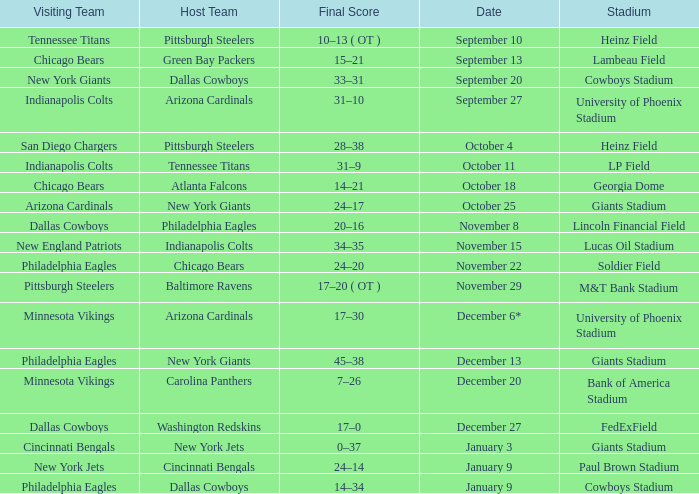Parse the table in full. {'header': ['Visiting Team', 'Host Team', 'Final Score', 'Date', 'Stadium'], 'rows': [['Tennessee Titans', 'Pittsburgh Steelers', '10–13 ( OT )', 'September 10', 'Heinz Field'], ['Chicago Bears', 'Green Bay Packers', '15–21', 'September 13', 'Lambeau Field'], ['New York Giants', 'Dallas Cowboys', '33–31', 'September 20', 'Cowboys Stadium'], ['Indianapolis Colts', 'Arizona Cardinals', '31–10', 'September 27', 'University of Phoenix Stadium'], ['San Diego Chargers', 'Pittsburgh Steelers', '28–38', 'October 4', 'Heinz Field'], ['Indianapolis Colts', 'Tennessee Titans', '31–9', 'October 11', 'LP Field'], ['Chicago Bears', 'Atlanta Falcons', '14–21', 'October 18', 'Georgia Dome'], ['Arizona Cardinals', 'New York Giants', '24–17', 'October 25', 'Giants Stadium'], ['Dallas Cowboys', 'Philadelphia Eagles', '20–16', 'November 8', 'Lincoln Financial Field'], ['New England Patriots', 'Indianapolis Colts', '34–35', 'November 15', 'Lucas Oil Stadium'], ['Philadelphia Eagles', 'Chicago Bears', '24–20', 'November 22', 'Soldier Field'], ['Pittsburgh Steelers', 'Baltimore Ravens', '17–20 ( OT )', 'November 29', 'M&T Bank Stadium'], ['Minnesota Vikings', 'Arizona Cardinals', '17–30', 'December 6*', 'University of Phoenix Stadium'], ['Philadelphia Eagles', 'New York Giants', '45–38', 'December 13', 'Giants Stadium'], ['Minnesota Vikings', 'Carolina Panthers', '7–26', 'December 20', 'Bank of America Stadium'], ['Dallas Cowboys', 'Washington Redskins', '17–0', 'December 27', 'FedExField'], ['Cincinnati Bengals', 'New York Jets', '0–37', 'January 3', 'Giants Stadium'], ['New York Jets', 'Cincinnati Bengals', '24–14', 'January 9', 'Paul Brown Stadium'], ['Philadelphia Eagles', 'Dallas Cowboys', '14–34', 'January 9', 'Cowboys Stadium']]} Tell me the visiting team for october 4 San Diego Chargers. 